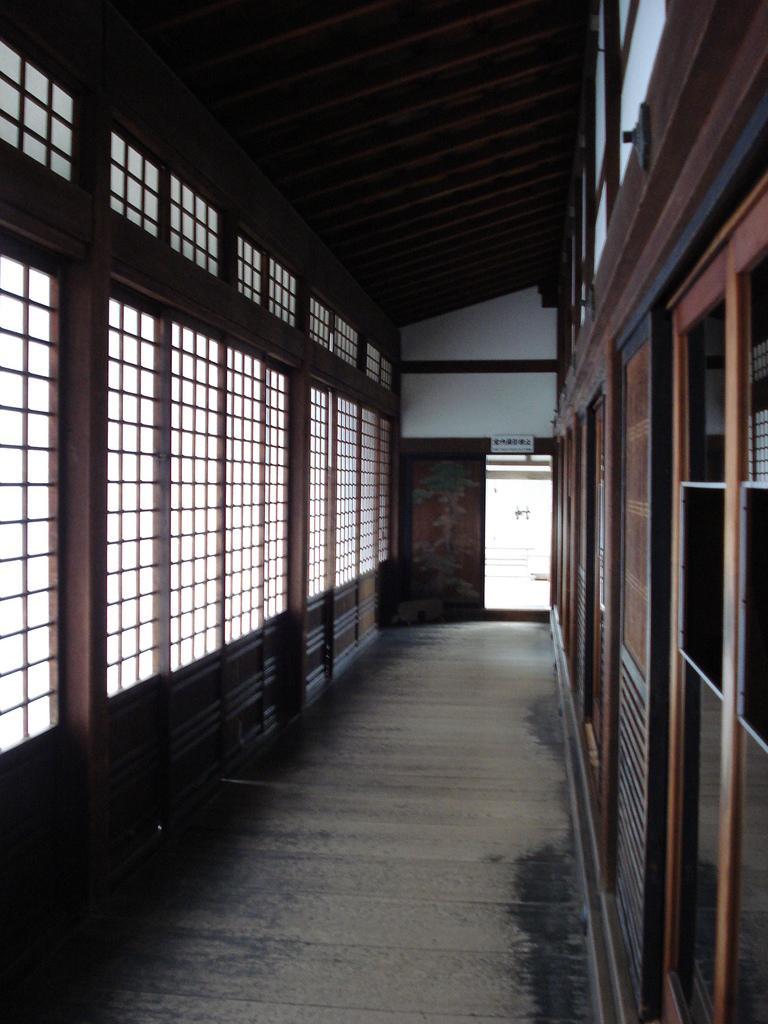Can you describe this image briefly? This picture is clicked inside the building. At the bottom, we see the floor. On the right side, we see the wooden wall and the window. On the left side, we see the windows. In the background, we see the door and a board in white color with some text written on it. We even see the white wall. At the top, we see the roof of the building. 